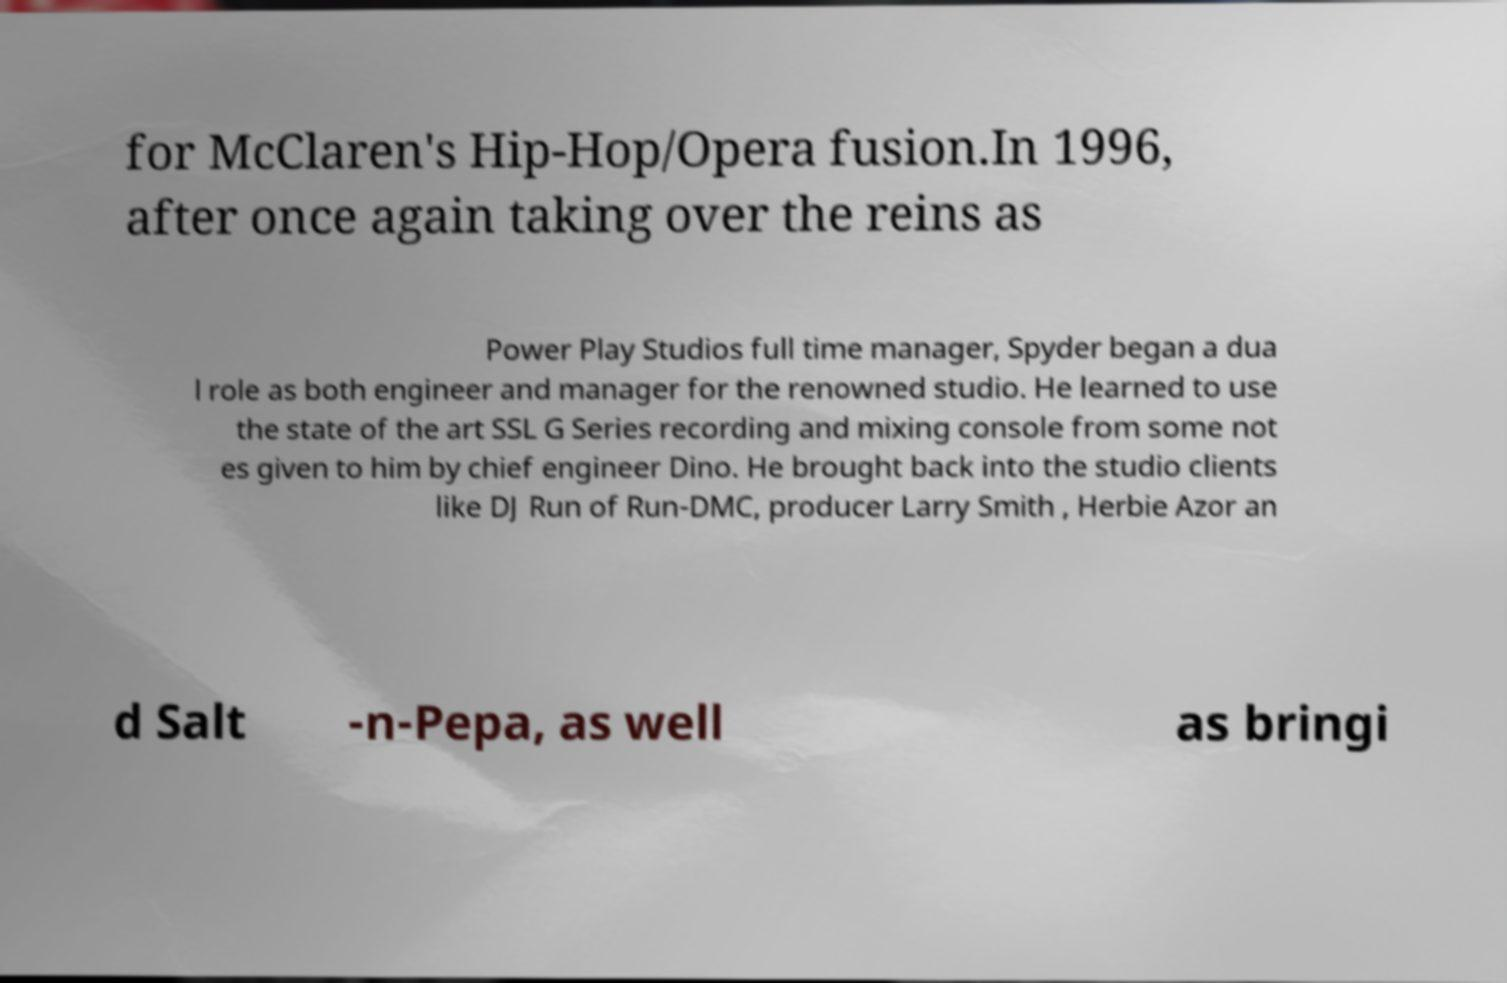What messages or text are displayed in this image? I need them in a readable, typed format. for McClaren's Hip-Hop/Opera fusion.In 1996, after once again taking over the reins as Power Play Studios full time manager, Spyder began a dua l role as both engineer and manager for the renowned studio. He learned to use the state of the art SSL G Series recording and mixing console from some not es given to him by chief engineer Dino. He brought back into the studio clients like DJ Run of Run-DMC, producer Larry Smith , Herbie Azor an d Salt -n-Pepa, as well as bringi 